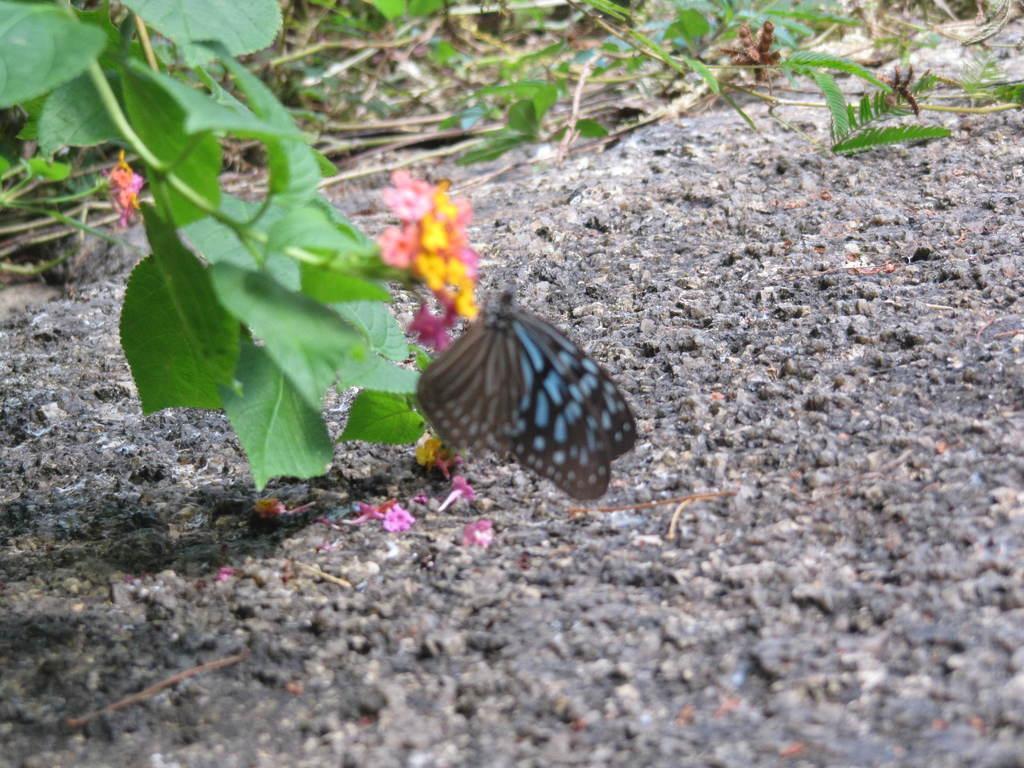Describe this image in one or two sentences. In this image we can see a butterfly on the flowers of a plant. We can also see leaves and some flowers on the ground. 